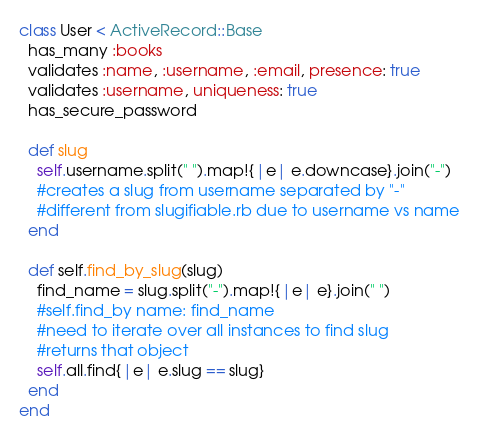Convert code to text. <code><loc_0><loc_0><loc_500><loc_500><_Ruby_>class User < ActiveRecord::Base
  has_many :books
  validates :name, :username, :email, presence: true
  validates :username, uniqueness: true
  has_secure_password

  def slug
    self.username.split(" ").map!{|e| e.downcase}.join("-")
    #creates a slug from username separated by "-"
    #different from slugifiable.rb due to username vs name
  end

  def self.find_by_slug(slug)
    find_name = slug.split("-").map!{|e| e}.join(" ")
    #self.find_by name: find_name
    #need to iterate over all instances to find slug
    #returns that object
    self.all.find{|e| e.slug == slug}
  end
end
</code> 